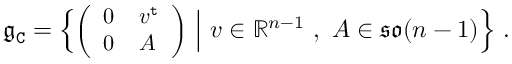<formula> <loc_0><loc_0><loc_500><loc_500>\mathfrak { g } _ { C } = \Big \{ { \Big ( \begin{array} { l l } { 0 } & { v ^ { t } } \\ { 0 } & { A } \end{array} \Big ) } \ \Big | \ v \in \mathbb { R } ^ { n - 1 } \ , \ A \in \mathfrak { s o } ( n - 1 ) \Big \} \ .</formula> 